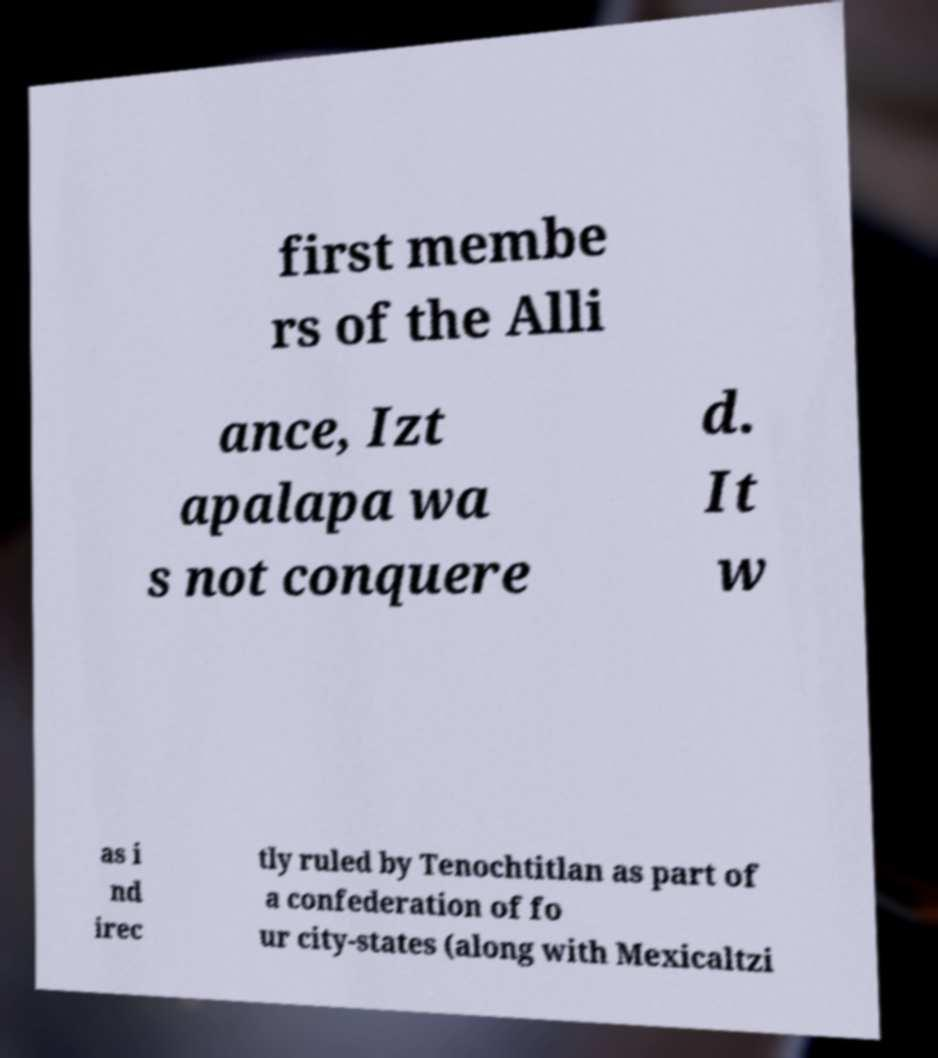Could you extract and type out the text from this image? first membe rs of the Alli ance, Izt apalapa wa s not conquere d. It w as i nd irec tly ruled by Tenochtitlan as part of a confederation of fo ur city-states (along with Mexicaltzi 